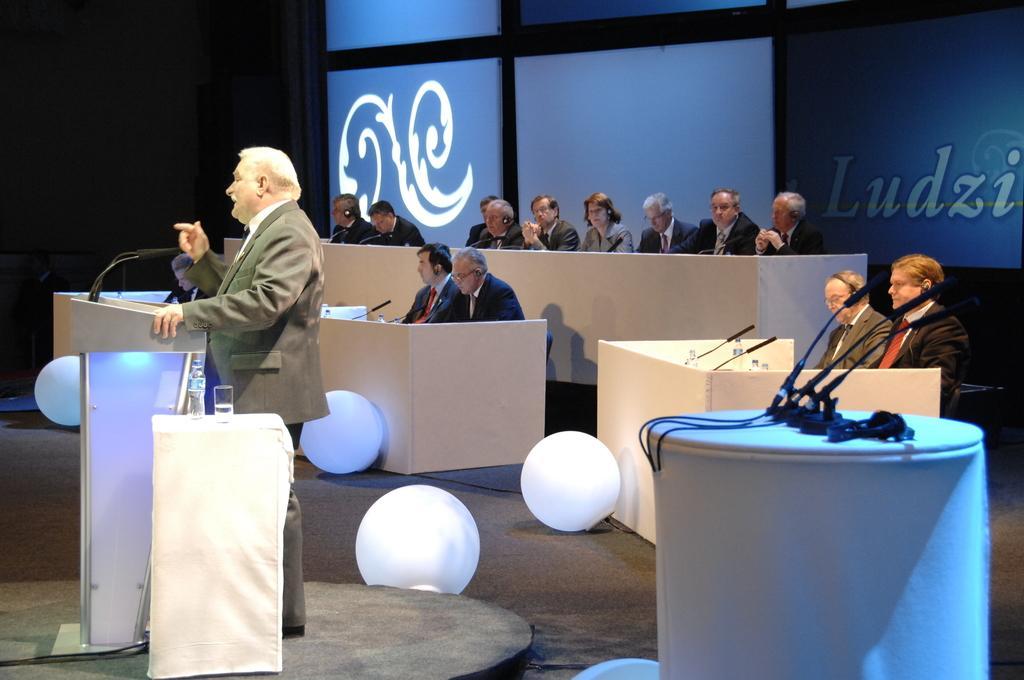Can you describe this image briefly? In this image there are group of people sitting in chair and a man standing near the podium , there is water bottle , glass in table , there are light balls. 